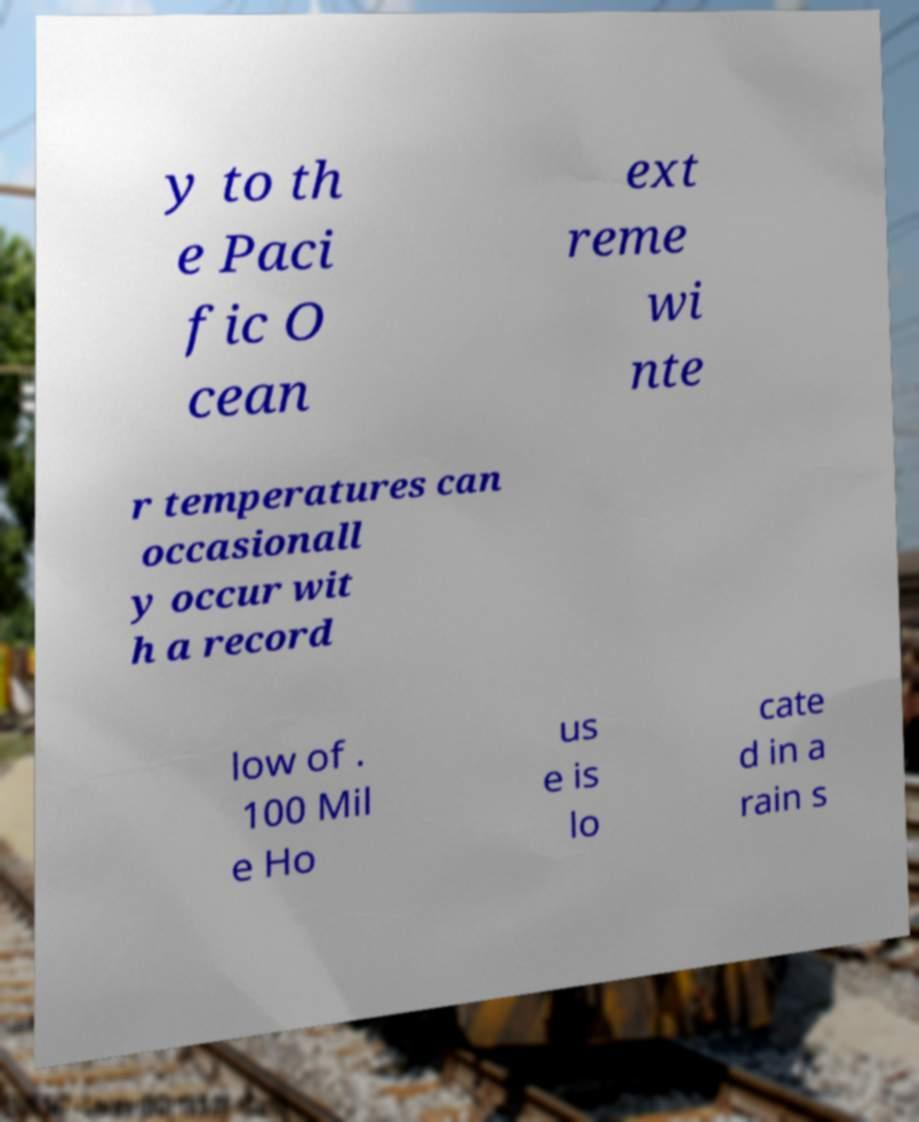Could you assist in decoding the text presented in this image and type it out clearly? y to th e Paci fic O cean ext reme wi nte r temperatures can occasionall y occur wit h a record low of . 100 Mil e Ho us e is lo cate d in a rain s 